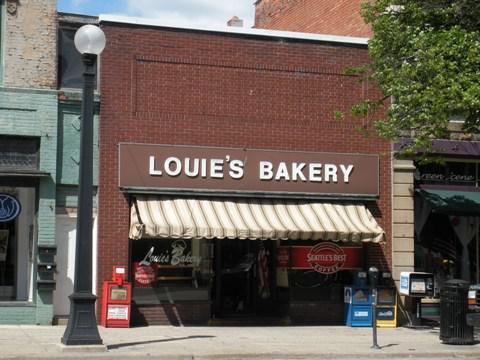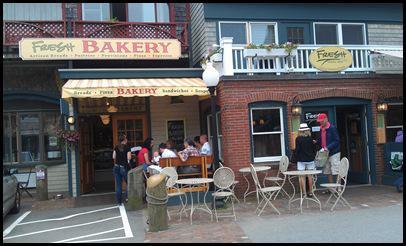The first image is the image on the left, the second image is the image on the right. For the images shown, is this caption "there is a brick building with a blue fabric awning, above the awning is a white painted window" true? Answer yes or no. No. The first image is the image on the left, the second image is the image on the right. Assess this claim about the two images: "The building in one of the images has a blue awning.". Correct or not? Answer yes or no. No. 